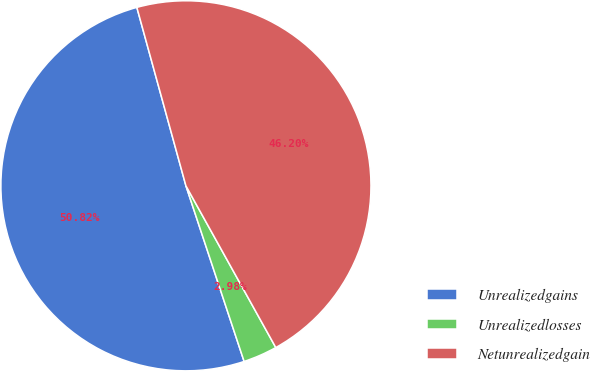<chart> <loc_0><loc_0><loc_500><loc_500><pie_chart><fcel>Unrealizedgains<fcel>Unrealizedlosses<fcel>Netunrealizedgain<nl><fcel>50.82%<fcel>2.98%<fcel>46.2%<nl></chart> 